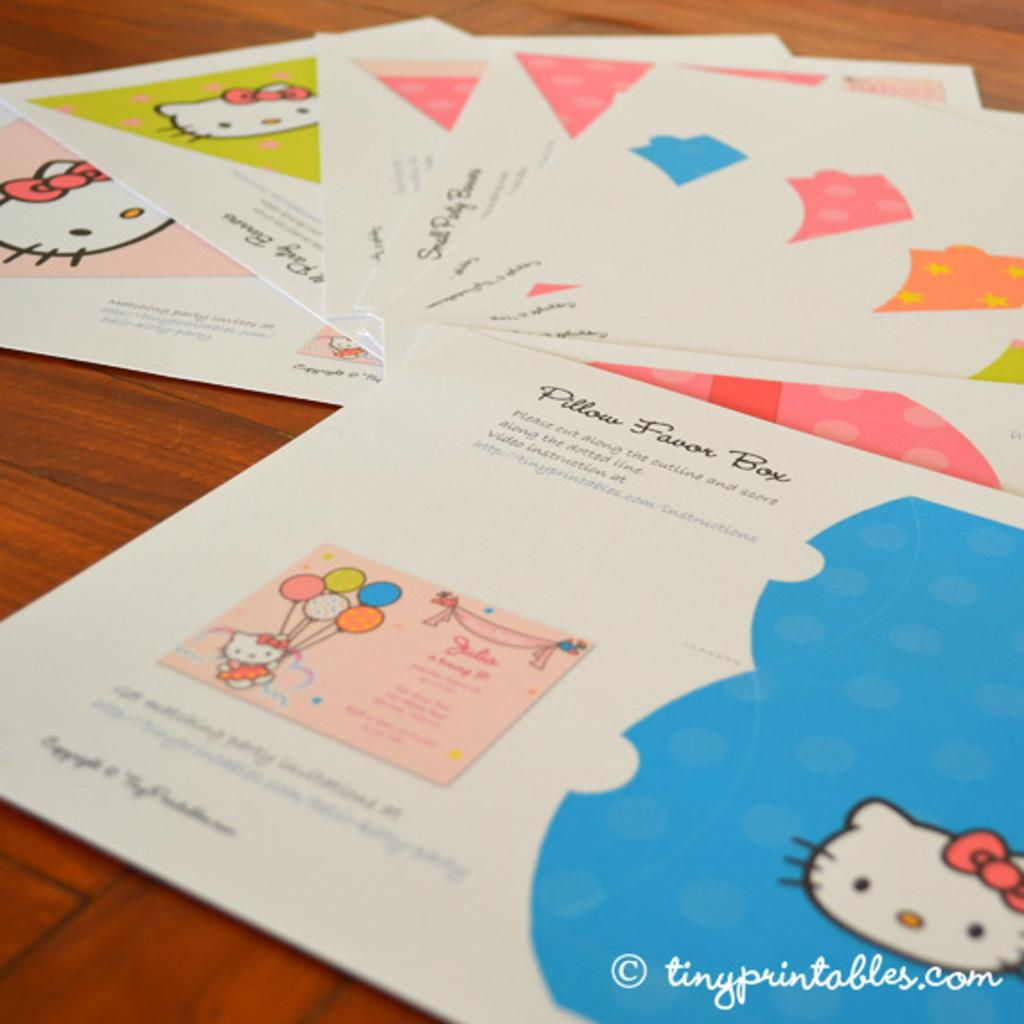<image>
Offer a succinct explanation of the picture presented. the cards for the Pillow Favor Box havae hello Kitty on them 